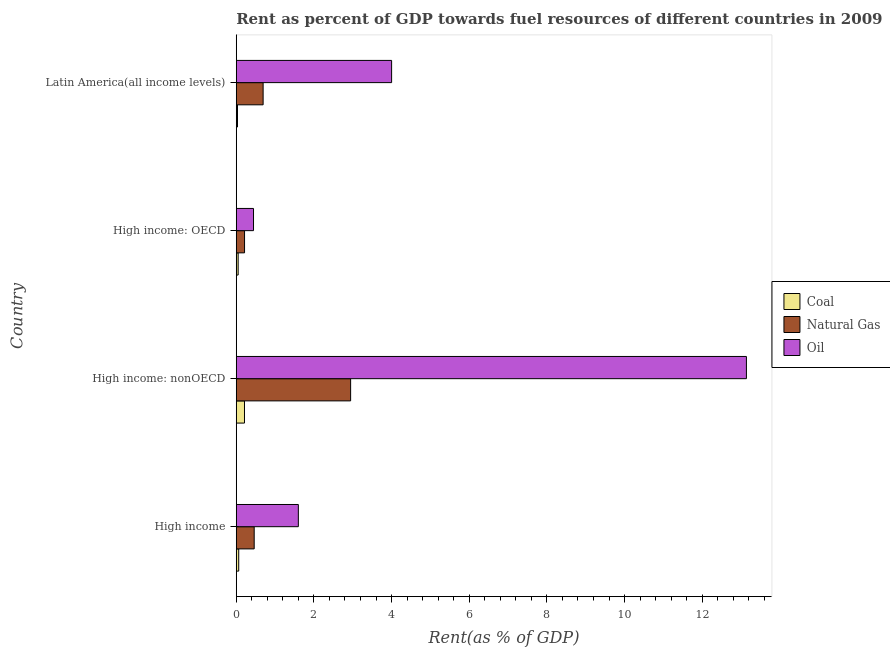How many different coloured bars are there?
Your response must be concise. 3. How many groups of bars are there?
Offer a very short reply. 4. Are the number of bars on each tick of the Y-axis equal?
Your response must be concise. Yes. How many bars are there on the 1st tick from the top?
Make the answer very short. 3. What is the label of the 3rd group of bars from the top?
Ensure brevity in your answer.  High income: nonOECD. In how many cases, is the number of bars for a given country not equal to the number of legend labels?
Make the answer very short. 0. What is the rent towards natural gas in Latin America(all income levels)?
Offer a very short reply. 0.69. Across all countries, what is the maximum rent towards coal?
Offer a terse response. 0.21. Across all countries, what is the minimum rent towards oil?
Your answer should be compact. 0.44. In which country was the rent towards natural gas maximum?
Your response must be concise. High income: nonOECD. In which country was the rent towards coal minimum?
Your response must be concise. Latin America(all income levels). What is the total rent towards oil in the graph?
Provide a short and direct response. 19.18. What is the difference between the rent towards coal in High income: OECD and that in High income: nonOECD?
Provide a short and direct response. -0.16. What is the difference between the rent towards oil in High income and the rent towards natural gas in High income: OECD?
Offer a terse response. 1.39. What is the average rent towards coal per country?
Make the answer very short. 0.09. What is the difference between the rent towards oil and rent towards natural gas in High income: nonOECD?
Your answer should be very brief. 10.19. What is the ratio of the rent towards coal in High income to that in High income: nonOECD?
Give a very brief answer. 0.3. Is the rent towards natural gas in High income: OECD less than that in High income: nonOECD?
Provide a short and direct response. Yes. Is the difference between the rent towards coal in High income and High income: nonOECD greater than the difference between the rent towards natural gas in High income and High income: nonOECD?
Your answer should be compact. Yes. What is the difference between the highest and the second highest rent towards oil?
Your answer should be compact. 9.14. What is the difference between the highest and the lowest rent towards natural gas?
Your answer should be very brief. 2.73. In how many countries, is the rent towards natural gas greater than the average rent towards natural gas taken over all countries?
Provide a short and direct response. 1. What does the 2nd bar from the top in High income represents?
Offer a very short reply. Natural Gas. What does the 1st bar from the bottom in Latin America(all income levels) represents?
Your response must be concise. Coal. Is it the case that in every country, the sum of the rent towards coal and rent towards natural gas is greater than the rent towards oil?
Offer a very short reply. No. How many bars are there?
Ensure brevity in your answer.  12. How many countries are there in the graph?
Ensure brevity in your answer.  4. What is the difference between two consecutive major ticks on the X-axis?
Your response must be concise. 2. How are the legend labels stacked?
Provide a succinct answer. Vertical. What is the title of the graph?
Keep it short and to the point. Rent as percent of GDP towards fuel resources of different countries in 2009. Does "Errors" appear as one of the legend labels in the graph?
Keep it short and to the point. No. What is the label or title of the X-axis?
Keep it short and to the point. Rent(as % of GDP). What is the Rent(as % of GDP) of Coal in High income?
Your answer should be compact. 0.06. What is the Rent(as % of GDP) of Natural Gas in High income?
Offer a very short reply. 0.46. What is the Rent(as % of GDP) in Oil in High income?
Your answer should be very brief. 1.6. What is the Rent(as % of GDP) in Coal in High income: nonOECD?
Make the answer very short. 0.21. What is the Rent(as % of GDP) of Natural Gas in High income: nonOECD?
Your answer should be very brief. 2.95. What is the Rent(as % of GDP) in Oil in High income: nonOECD?
Your response must be concise. 13.14. What is the Rent(as % of GDP) of Coal in High income: OECD?
Your answer should be compact. 0.05. What is the Rent(as % of GDP) of Natural Gas in High income: OECD?
Give a very brief answer. 0.21. What is the Rent(as % of GDP) in Oil in High income: OECD?
Your answer should be compact. 0.44. What is the Rent(as % of GDP) of Coal in Latin America(all income levels)?
Ensure brevity in your answer.  0.03. What is the Rent(as % of GDP) in Natural Gas in Latin America(all income levels)?
Offer a very short reply. 0.69. What is the Rent(as % of GDP) in Oil in Latin America(all income levels)?
Your answer should be compact. 4. Across all countries, what is the maximum Rent(as % of GDP) in Coal?
Make the answer very short. 0.21. Across all countries, what is the maximum Rent(as % of GDP) in Natural Gas?
Offer a very short reply. 2.95. Across all countries, what is the maximum Rent(as % of GDP) of Oil?
Make the answer very short. 13.14. Across all countries, what is the minimum Rent(as % of GDP) in Coal?
Provide a succinct answer. 0.03. Across all countries, what is the minimum Rent(as % of GDP) in Natural Gas?
Provide a short and direct response. 0.21. Across all countries, what is the minimum Rent(as % of GDP) of Oil?
Offer a very short reply. 0.44. What is the total Rent(as % of GDP) of Coal in the graph?
Your response must be concise. 0.36. What is the total Rent(as % of GDP) in Natural Gas in the graph?
Provide a succinct answer. 4.31. What is the total Rent(as % of GDP) in Oil in the graph?
Your answer should be compact. 19.18. What is the difference between the Rent(as % of GDP) of Coal in High income and that in High income: nonOECD?
Provide a short and direct response. -0.15. What is the difference between the Rent(as % of GDP) in Natural Gas in High income and that in High income: nonOECD?
Offer a very short reply. -2.48. What is the difference between the Rent(as % of GDP) in Oil in High income and that in High income: nonOECD?
Offer a terse response. -11.54. What is the difference between the Rent(as % of GDP) of Coal in High income and that in High income: OECD?
Your answer should be very brief. 0.01. What is the difference between the Rent(as % of GDP) in Natural Gas in High income and that in High income: OECD?
Make the answer very short. 0.25. What is the difference between the Rent(as % of GDP) of Oil in High income and that in High income: OECD?
Your response must be concise. 1.15. What is the difference between the Rent(as % of GDP) in Coal in High income and that in Latin America(all income levels)?
Provide a short and direct response. 0.03. What is the difference between the Rent(as % of GDP) in Natural Gas in High income and that in Latin America(all income levels)?
Offer a terse response. -0.23. What is the difference between the Rent(as % of GDP) in Oil in High income and that in Latin America(all income levels)?
Make the answer very short. -2.4. What is the difference between the Rent(as % of GDP) in Coal in High income: nonOECD and that in High income: OECD?
Offer a very short reply. 0.16. What is the difference between the Rent(as % of GDP) in Natural Gas in High income: nonOECD and that in High income: OECD?
Your answer should be compact. 2.73. What is the difference between the Rent(as % of GDP) of Oil in High income: nonOECD and that in High income: OECD?
Offer a very short reply. 12.69. What is the difference between the Rent(as % of GDP) of Coal in High income: nonOECD and that in Latin America(all income levels)?
Your answer should be very brief. 0.18. What is the difference between the Rent(as % of GDP) in Natural Gas in High income: nonOECD and that in Latin America(all income levels)?
Make the answer very short. 2.25. What is the difference between the Rent(as % of GDP) of Oil in High income: nonOECD and that in Latin America(all income levels)?
Make the answer very short. 9.14. What is the difference between the Rent(as % of GDP) of Coal in High income: OECD and that in Latin America(all income levels)?
Offer a very short reply. 0.02. What is the difference between the Rent(as % of GDP) of Natural Gas in High income: OECD and that in Latin America(all income levels)?
Make the answer very short. -0.48. What is the difference between the Rent(as % of GDP) of Oil in High income: OECD and that in Latin America(all income levels)?
Offer a very short reply. -3.56. What is the difference between the Rent(as % of GDP) in Coal in High income and the Rent(as % of GDP) in Natural Gas in High income: nonOECD?
Provide a short and direct response. -2.88. What is the difference between the Rent(as % of GDP) in Coal in High income and the Rent(as % of GDP) in Oil in High income: nonOECD?
Give a very brief answer. -13.07. What is the difference between the Rent(as % of GDP) in Natural Gas in High income and the Rent(as % of GDP) in Oil in High income: nonOECD?
Offer a terse response. -12.68. What is the difference between the Rent(as % of GDP) of Coal in High income and the Rent(as % of GDP) of Oil in High income: OECD?
Make the answer very short. -0.38. What is the difference between the Rent(as % of GDP) of Natural Gas in High income and the Rent(as % of GDP) of Oil in High income: OECD?
Offer a terse response. 0.02. What is the difference between the Rent(as % of GDP) of Coal in High income and the Rent(as % of GDP) of Natural Gas in Latin America(all income levels)?
Your answer should be compact. -0.63. What is the difference between the Rent(as % of GDP) of Coal in High income and the Rent(as % of GDP) of Oil in Latin America(all income levels)?
Your answer should be very brief. -3.94. What is the difference between the Rent(as % of GDP) in Natural Gas in High income and the Rent(as % of GDP) in Oil in Latin America(all income levels)?
Your response must be concise. -3.54. What is the difference between the Rent(as % of GDP) of Coal in High income: nonOECD and the Rent(as % of GDP) of Natural Gas in High income: OECD?
Your answer should be very brief. -0. What is the difference between the Rent(as % of GDP) of Coal in High income: nonOECD and the Rent(as % of GDP) of Oil in High income: OECD?
Your answer should be very brief. -0.23. What is the difference between the Rent(as % of GDP) of Natural Gas in High income: nonOECD and the Rent(as % of GDP) of Oil in High income: OECD?
Provide a short and direct response. 2.5. What is the difference between the Rent(as % of GDP) of Coal in High income: nonOECD and the Rent(as % of GDP) of Natural Gas in Latin America(all income levels)?
Your response must be concise. -0.48. What is the difference between the Rent(as % of GDP) of Coal in High income: nonOECD and the Rent(as % of GDP) of Oil in Latin America(all income levels)?
Your answer should be very brief. -3.79. What is the difference between the Rent(as % of GDP) of Natural Gas in High income: nonOECD and the Rent(as % of GDP) of Oil in Latin America(all income levels)?
Give a very brief answer. -1.06. What is the difference between the Rent(as % of GDP) of Coal in High income: OECD and the Rent(as % of GDP) of Natural Gas in Latin America(all income levels)?
Your answer should be compact. -0.64. What is the difference between the Rent(as % of GDP) of Coal in High income: OECD and the Rent(as % of GDP) of Oil in Latin America(all income levels)?
Make the answer very short. -3.95. What is the difference between the Rent(as % of GDP) in Natural Gas in High income: OECD and the Rent(as % of GDP) in Oil in Latin America(all income levels)?
Your response must be concise. -3.79. What is the average Rent(as % of GDP) of Coal per country?
Make the answer very short. 0.09. What is the average Rent(as % of GDP) in Natural Gas per country?
Make the answer very short. 1.08. What is the average Rent(as % of GDP) in Oil per country?
Your response must be concise. 4.8. What is the difference between the Rent(as % of GDP) in Coal and Rent(as % of GDP) in Natural Gas in High income?
Keep it short and to the point. -0.4. What is the difference between the Rent(as % of GDP) in Coal and Rent(as % of GDP) in Oil in High income?
Give a very brief answer. -1.54. What is the difference between the Rent(as % of GDP) in Natural Gas and Rent(as % of GDP) in Oil in High income?
Your answer should be very brief. -1.14. What is the difference between the Rent(as % of GDP) in Coal and Rent(as % of GDP) in Natural Gas in High income: nonOECD?
Your answer should be very brief. -2.73. What is the difference between the Rent(as % of GDP) in Coal and Rent(as % of GDP) in Oil in High income: nonOECD?
Your response must be concise. -12.93. What is the difference between the Rent(as % of GDP) in Natural Gas and Rent(as % of GDP) in Oil in High income: nonOECD?
Ensure brevity in your answer.  -10.19. What is the difference between the Rent(as % of GDP) of Coal and Rent(as % of GDP) of Natural Gas in High income: OECD?
Your answer should be very brief. -0.16. What is the difference between the Rent(as % of GDP) of Coal and Rent(as % of GDP) of Oil in High income: OECD?
Your answer should be compact. -0.4. What is the difference between the Rent(as % of GDP) of Natural Gas and Rent(as % of GDP) of Oil in High income: OECD?
Make the answer very short. -0.23. What is the difference between the Rent(as % of GDP) of Coal and Rent(as % of GDP) of Natural Gas in Latin America(all income levels)?
Provide a short and direct response. -0.66. What is the difference between the Rent(as % of GDP) of Coal and Rent(as % of GDP) of Oil in Latin America(all income levels)?
Provide a short and direct response. -3.97. What is the difference between the Rent(as % of GDP) in Natural Gas and Rent(as % of GDP) in Oil in Latin America(all income levels)?
Provide a succinct answer. -3.31. What is the ratio of the Rent(as % of GDP) of Coal in High income to that in High income: nonOECD?
Your response must be concise. 0.3. What is the ratio of the Rent(as % of GDP) of Natural Gas in High income to that in High income: nonOECD?
Offer a terse response. 0.16. What is the ratio of the Rent(as % of GDP) of Oil in High income to that in High income: nonOECD?
Provide a succinct answer. 0.12. What is the ratio of the Rent(as % of GDP) of Coal in High income to that in High income: OECD?
Give a very brief answer. 1.3. What is the ratio of the Rent(as % of GDP) of Natural Gas in High income to that in High income: OECD?
Your response must be concise. 2.16. What is the ratio of the Rent(as % of GDP) of Oil in High income to that in High income: OECD?
Your answer should be very brief. 3.6. What is the ratio of the Rent(as % of GDP) in Coal in High income to that in Latin America(all income levels)?
Keep it short and to the point. 1.99. What is the ratio of the Rent(as % of GDP) of Natural Gas in High income to that in Latin America(all income levels)?
Keep it short and to the point. 0.67. What is the ratio of the Rent(as % of GDP) in Oil in High income to that in Latin America(all income levels)?
Your response must be concise. 0.4. What is the ratio of the Rent(as % of GDP) of Coal in High income: nonOECD to that in High income: OECD?
Keep it short and to the point. 4.34. What is the ratio of the Rent(as % of GDP) of Natural Gas in High income: nonOECD to that in High income: OECD?
Offer a terse response. 13.79. What is the ratio of the Rent(as % of GDP) in Oil in High income: nonOECD to that in High income: OECD?
Give a very brief answer. 29.56. What is the ratio of the Rent(as % of GDP) in Coal in High income: nonOECD to that in Latin America(all income levels)?
Make the answer very short. 6.62. What is the ratio of the Rent(as % of GDP) of Natural Gas in High income: nonOECD to that in Latin America(all income levels)?
Your answer should be compact. 4.26. What is the ratio of the Rent(as % of GDP) of Oil in High income: nonOECD to that in Latin America(all income levels)?
Offer a terse response. 3.28. What is the ratio of the Rent(as % of GDP) of Coal in High income: OECD to that in Latin America(all income levels)?
Give a very brief answer. 1.52. What is the ratio of the Rent(as % of GDP) in Natural Gas in High income: OECD to that in Latin America(all income levels)?
Your answer should be compact. 0.31. What is the difference between the highest and the second highest Rent(as % of GDP) of Coal?
Make the answer very short. 0.15. What is the difference between the highest and the second highest Rent(as % of GDP) of Natural Gas?
Your response must be concise. 2.25. What is the difference between the highest and the second highest Rent(as % of GDP) in Oil?
Offer a very short reply. 9.14. What is the difference between the highest and the lowest Rent(as % of GDP) in Coal?
Your answer should be compact. 0.18. What is the difference between the highest and the lowest Rent(as % of GDP) in Natural Gas?
Provide a short and direct response. 2.73. What is the difference between the highest and the lowest Rent(as % of GDP) of Oil?
Provide a short and direct response. 12.69. 